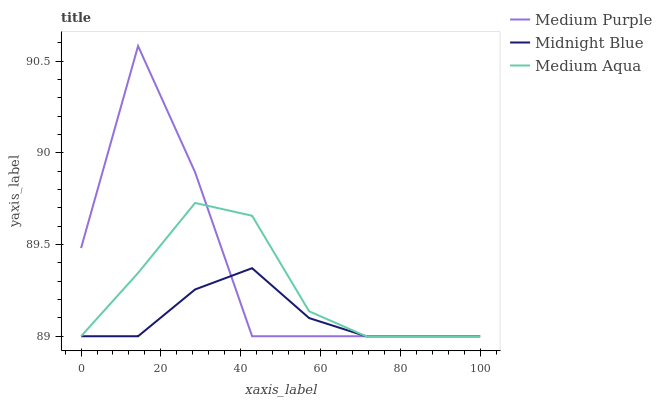Does Midnight Blue have the minimum area under the curve?
Answer yes or no. Yes. Does Medium Purple have the maximum area under the curve?
Answer yes or no. Yes. Does Medium Aqua have the minimum area under the curve?
Answer yes or no. No. Does Medium Aqua have the maximum area under the curve?
Answer yes or no. No. Is Midnight Blue the smoothest?
Answer yes or no. Yes. Is Medium Purple the roughest?
Answer yes or no. Yes. Is Medium Aqua the smoothest?
Answer yes or no. No. Is Medium Aqua the roughest?
Answer yes or no. No. Does Medium Purple have the lowest value?
Answer yes or no. Yes. Does Medium Purple have the highest value?
Answer yes or no. Yes. Does Medium Aqua have the highest value?
Answer yes or no. No. Does Medium Purple intersect Medium Aqua?
Answer yes or no. Yes. Is Medium Purple less than Medium Aqua?
Answer yes or no. No. Is Medium Purple greater than Medium Aqua?
Answer yes or no. No. 